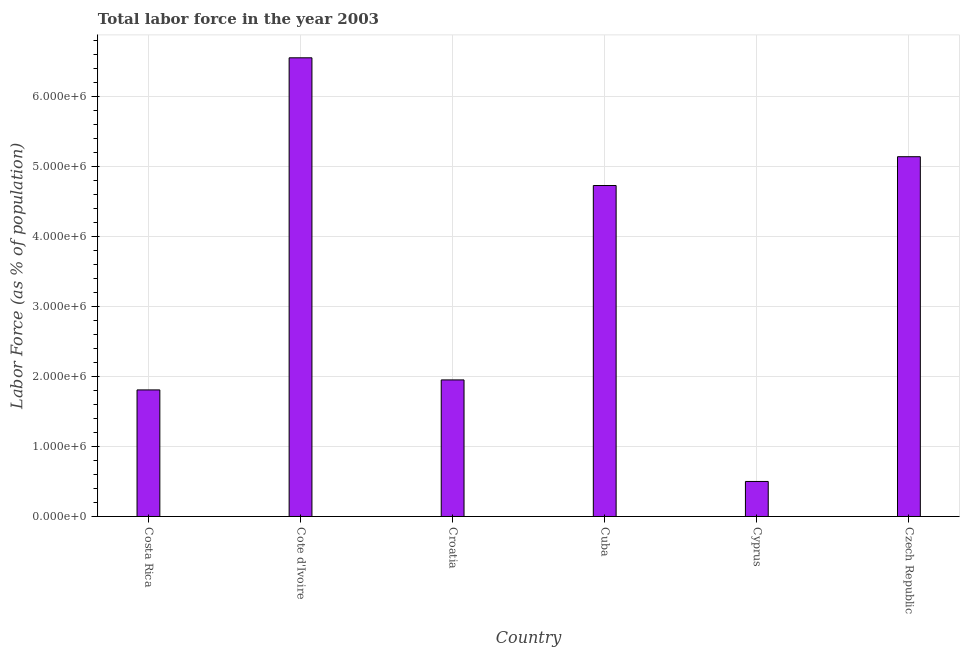Does the graph contain any zero values?
Provide a short and direct response. No. Does the graph contain grids?
Your answer should be very brief. Yes. What is the title of the graph?
Your answer should be compact. Total labor force in the year 2003. What is the label or title of the X-axis?
Your response must be concise. Country. What is the label or title of the Y-axis?
Your response must be concise. Labor Force (as % of population). What is the total labor force in Costa Rica?
Your answer should be very brief. 1.81e+06. Across all countries, what is the maximum total labor force?
Your answer should be compact. 6.55e+06. Across all countries, what is the minimum total labor force?
Your answer should be very brief. 5.00e+05. In which country was the total labor force maximum?
Your answer should be compact. Cote d'Ivoire. In which country was the total labor force minimum?
Make the answer very short. Cyprus. What is the sum of the total labor force?
Offer a terse response. 2.07e+07. What is the difference between the total labor force in Cuba and Cyprus?
Your answer should be very brief. 4.23e+06. What is the average total labor force per country?
Your answer should be compact. 3.45e+06. What is the median total labor force?
Provide a short and direct response. 3.34e+06. What is the ratio of the total labor force in Croatia to that in Czech Republic?
Your answer should be compact. 0.38. What is the difference between the highest and the second highest total labor force?
Make the answer very short. 1.41e+06. Is the sum of the total labor force in Croatia and Cyprus greater than the maximum total labor force across all countries?
Ensure brevity in your answer.  No. What is the difference between the highest and the lowest total labor force?
Offer a very short reply. 6.05e+06. In how many countries, is the total labor force greater than the average total labor force taken over all countries?
Make the answer very short. 3. How many bars are there?
Offer a very short reply. 6. Are all the bars in the graph horizontal?
Provide a short and direct response. No. What is the difference between two consecutive major ticks on the Y-axis?
Your answer should be compact. 1.00e+06. What is the Labor Force (as % of population) of Costa Rica?
Offer a very short reply. 1.81e+06. What is the Labor Force (as % of population) in Cote d'Ivoire?
Give a very brief answer. 6.55e+06. What is the Labor Force (as % of population) in Croatia?
Ensure brevity in your answer.  1.95e+06. What is the Labor Force (as % of population) of Cuba?
Keep it short and to the point. 4.73e+06. What is the Labor Force (as % of population) in Cyprus?
Provide a succinct answer. 5.00e+05. What is the Labor Force (as % of population) of Czech Republic?
Provide a short and direct response. 5.14e+06. What is the difference between the Labor Force (as % of population) in Costa Rica and Cote d'Ivoire?
Keep it short and to the point. -4.74e+06. What is the difference between the Labor Force (as % of population) in Costa Rica and Croatia?
Your answer should be very brief. -1.43e+05. What is the difference between the Labor Force (as % of population) in Costa Rica and Cuba?
Your answer should be compact. -2.92e+06. What is the difference between the Labor Force (as % of population) in Costa Rica and Cyprus?
Give a very brief answer. 1.31e+06. What is the difference between the Labor Force (as % of population) in Costa Rica and Czech Republic?
Offer a very short reply. -3.33e+06. What is the difference between the Labor Force (as % of population) in Cote d'Ivoire and Croatia?
Your response must be concise. 4.60e+06. What is the difference between the Labor Force (as % of population) in Cote d'Ivoire and Cuba?
Give a very brief answer. 1.82e+06. What is the difference between the Labor Force (as % of population) in Cote d'Ivoire and Cyprus?
Keep it short and to the point. 6.05e+06. What is the difference between the Labor Force (as % of population) in Cote d'Ivoire and Czech Republic?
Provide a succinct answer. 1.41e+06. What is the difference between the Labor Force (as % of population) in Croatia and Cuba?
Give a very brief answer. -2.78e+06. What is the difference between the Labor Force (as % of population) in Croatia and Cyprus?
Offer a terse response. 1.45e+06. What is the difference between the Labor Force (as % of population) in Croatia and Czech Republic?
Your answer should be compact. -3.19e+06. What is the difference between the Labor Force (as % of population) in Cuba and Cyprus?
Provide a succinct answer. 4.23e+06. What is the difference between the Labor Force (as % of population) in Cuba and Czech Republic?
Keep it short and to the point. -4.11e+05. What is the difference between the Labor Force (as % of population) in Cyprus and Czech Republic?
Your response must be concise. -4.64e+06. What is the ratio of the Labor Force (as % of population) in Costa Rica to that in Cote d'Ivoire?
Keep it short and to the point. 0.28. What is the ratio of the Labor Force (as % of population) in Costa Rica to that in Croatia?
Give a very brief answer. 0.93. What is the ratio of the Labor Force (as % of population) in Costa Rica to that in Cuba?
Make the answer very short. 0.38. What is the ratio of the Labor Force (as % of population) in Costa Rica to that in Cyprus?
Offer a very short reply. 3.61. What is the ratio of the Labor Force (as % of population) in Costa Rica to that in Czech Republic?
Make the answer very short. 0.35. What is the ratio of the Labor Force (as % of population) in Cote d'Ivoire to that in Croatia?
Keep it short and to the point. 3.36. What is the ratio of the Labor Force (as % of population) in Cote d'Ivoire to that in Cuba?
Provide a succinct answer. 1.39. What is the ratio of the Labor Force (as % of population) in Cote d'Ivoire to that in Cyprus?
Provide a succinct answer. 13.1. What is the ratio of the Labor Force (as % of population) in Cote d'Ivoire to that in Czech Republic?
Provide a short and direct response. 1.27. What is the ratio of the Labor Force (as % of population) in Croatia to that in Cuba?
Your answer should be very brief. 0.41. What is the ratio of the Labor Force (as % of population) in Croatia to that in Czech Republic?
Provide a short and direct response. 0.38. What is the ratio of the Labor Force (as % of population) in Cuba to that in Cyprus?
Keep it short and to the point. 9.45. What is the ratio of the Labor Force (as % of population) in Cuba to that in Czech Republic?
Offer a terse response. 0.92. What is the ratio of the Labor Force (as % of population) in Cyprus to that in Czech Republic?
Make the answer very short. 0.1. 